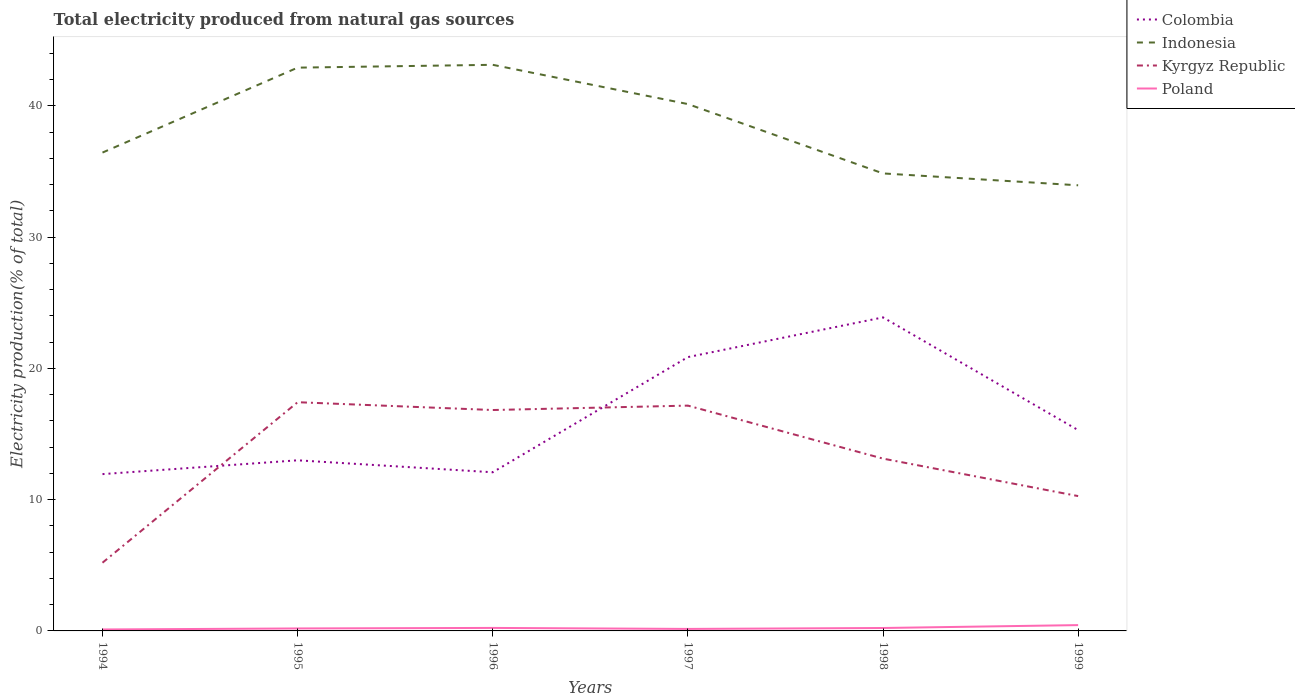Is the number of lines equal to the number of legend labels?
Provide a short and direct response. Yes. Across all years, what is the maximum total electricity produced in Colombia?
Offer a very short reply. 11.95. What is the total total electricity produced in Kyrgyz Republic in the graph?
Your response must be concise. -5.08. What is the difference between the highest and the second highest total electricity produced in Indonesia?
Your response must be concise. 9.18. How many years are there in the graph?
Provide a short and direct response. 6. Are the values on the major ticks of Y-axis written in scientific E-notation?
Offer a very short reply. No. Does the graph contain any zero values?
Offer a terse response. No. What is the title of the graph?
Keep it short and to the point. Total electricity produced from natural gas sources. What is the label or title of the X-axis?
Offer a terse response. Years. What is the label or title of the Y-axis?
Give a very brief answer. Electricity production(% of total). What is the Electricity production(% of total) of Colombia in 1994?
Your answer should be very brief. 11.95. What is the Electricity production(% of total) in Indonesia in 1994?
Keep it short and to the point. 36.44. What is the Electricity production(% of total) of Kyrgyz Republic in 1994?
Give a very brief answer. 5.2. What is the Electricity production(% of total) of Poland in 1994?
Offer a terse response. 0.11. What is the Electricity production(% of total) of Colombia in 1995?
Your response must be concise. 13. What is the Electricity production(% of total) in Indonesia in 1995?
Your answer should be very brief. 42.91. What is the Electricity production(% of total) of Kyrgyz Republic in 1995?
Offer a very short reply. 17.42. What is the Electricity production(% of total) in Poland in 1995?
Provide a short and direct response. 0.19. What is the Electricity production(% of total) in Colombia in 1996?
Offer a very short reply. 12.09. What is the Electricity production(% of total) of Indonesia in 1996?
Give a very brief answer. 43.13. What is the Electricity production(% of total) of Kyrgyz Republic in 1996?
Provide a short and direct response. 16.83. What is the Electricity production(% of total) in Poland in 1996?
Provide a succinct answer. 0.23. What is the Electricity production(% of total) of Colombia in 1997?
Give a very brief answer. 20.86. What is the Electricity production(% of total) of Indonesia in 1997?
Your response must be concise. 40.14. What is the Electricity production(% of total) in Kyrgyz Republic in 1997?
Offer a very short reply. 17.16. What is the Electricity production(% of total) in Poland in 1997?
Ensure brevity in your answer.  0.15. What is the Electricity production(% of total) of Colombia in 1998?
Your response must be concise. 23.89. What is the Electricity production(% of total) of Indonesia in 1998?
Provide a short and direct response. 34.85. What is the Electricity production(% of total) of Kyrgyz Republic in 1998?
Keep it short and to the point. 13.13. What is the Electricity production(% of total) of Poland in 1998?
Keep it short and to the point. 0.22. What is the Electricity production(% of total) of Colombia in 1999?
Ensure brevity in your answer.  15.3. What is the Electricity production(% of total) of Indonesia in 1999?
Offer a very short reply. 33.95. What is the Electricity production(% of total) in Kyrgyz Republic in 1999?
Make the answer very short. 10.27. What is the Electricity production(% of total) of Poland in 1999?
Your answer should be very brief. 0.44. Across all years, what is the maximum Electricity production(% of total) in Colombia?
Offer a very short reply. 23.89. Across all years, what is the maximum Electricity production(% of total) of Indonesia?
Provide a succinct answer. 43.13. Across all years, what is the maximum Electricity production(% of total) in Kyrgyz Republic?
Provide a succinct answer. 17.42. Across all years, what is the maximum Electricity production(% of total) of Poland?
Offer a very short reply. 0.44. Across all years, what is the minimum Electricity production(% of total) of Colombia?
Make the answer very short. 11.95. Across all years, what is the minimum Electricity production(% of total) in Indonesia?
Keep it short and to the point. 33.95. Across all years, what is the minimum Electricity production(% of total) in Kyrgyz Republic?
Make the answer very short. 5.2. Across all years, what is the minimum Electricity production(% of total) in Poland?
Provide a succinct answer. 0.11. What is the total Electricity production(% of total) of Colombia in the graph?
Your answer should be very brief. 97.08. What is the total Electricity production(% of total) in Indonesia in the graph?
Give a very brief answer. 231.42. What is the total Electricity production(% of total) in Kyrgyz Republic in the graph?
Your response must be concise. 80.01. What is the total Electricity production(% of total) in Poland in the graph?
Your answer should be very brief. 1.35. What is the difference between the Electricity production(% of total) in Colombia in 1994 and that in 1995?
Your answer should be compact. -1.05. What is the difference between the Electricity production(% of total) in Indonesia in 1994 and that in 1995?
Your answer should be compact. -6.47. What is the difference between the Electricity production(% of total) in Kyrgyz Republic in 1994 and that in 1995?
Offer a terse response. -12.23. What is the difference between the Electricity production(% of total) in Poland in 1994 and that in 1995?
Make the answer very short. -0.08. What is the difference between the Electricity production(% of total) of Colombia in 1994 and that in 1996?
Make the answer very short. -0.14. What is the difference between the Electricity production(% of total) in Indonesia in 1994 and that in 1996?
Your response must be concise. -6.69. What is the difference between the Electricity production(% of total) in Kyrgyz Republic in 1994 and that in 1996?
Provide a succinct answer. -11.63. What is the difference between the Electricity production(% of total) of Poland in 1994 and that in 1996?
Your response must be concise. -0.12. What is the difference between the Electricity production(% of total) of Colombia in 1994 and that in 1997?
Give a very brief answer. -8.91. What is the difference between the Electricity production(% of total) of Indonesia in 1994 and that in 1997?
Your answer should be compact. -3.69. What is the difference between the Electricity production(% of total) in Kyrgyz Republic in 1994 and that in 1997?
Offer a very short reply. -11.97. What is the difference between the Electricity production(% of total) of Poland in 1994 and that in 1997?
Provide a succinct answer. -0.04. What is the difference between the Electricity production(% of total) in Colombia in 1994 and that in 1998?
Your response must be concise. -11.94. What is the difference between the Electricity production(% of total) of Indonesia in 1994 and that in 1998?
Ensure brevity in your answer.  1.59. What is the difference between the Electricity production(% of total) in Kyrgyz Republic in 1994 and that in 1998?
Offer a very short reply. -7.93. What is the difference between the Electricity production(% of total) in Poland in 1994 and that in 1998?
Your answer should be compact. -0.11. What is the difference between the Electricity production(% of total) in Colombia in 1994 and that in 1999?
Ensure brevity in your answer.  -3.35. What is the difference between the Electricity production(% of total) of Indonesia in 1994 and that in 1999?
Provide a succinct answer. 2.49. What is the difference between the Electricity production(% of total) of Kyrgyz Republic in 1994 and that in 1999?
Keep it short and to the point. -5.08. What is the difference between the Electricity production(% of total) in Poland in 1994 and that in 1999?
Your answer should be very brief. -0.33. What is the difference between the Electricity production(% of total) of Colombia in 1995 and that in 1996?
Make the answer very short. 0.91. What is the difference between the Electricity production(% of total) in Indonesia in 1995 and that in 1996?
Give a very brief answer. -0.22. What is the difference between the Electricity production(% of total) of Kyrgyz Republic in 1995 and that in 1996?
Offer a terse response. 0.6. What is the difference between the Electricity production(% of total) of Poland in 1995 and that in 1996?
Ensure brevity in your answer.  -0.04. What is the difference between the Electricity production(% of total) in Colombia in 1995 and that in 1997?
Offer a terse response. -7.86. What is the difference between the Electricity production(% of total) in Indonesia in 1995 and that in 1997?
Keep it short and to the point. 2.78. What is the difference between the Electricity production(% of total) of Kyrgyz Republic in 1995 and that in 1997?
Your answer should be compact. 0.26. What is the difference between the Electricity production(% of total) of Poland in 1995 and that in 1997?
Give a very brief answer. 0.04. What is the difference between the Electricity production(% of total) in Colombia in 1995 and that in 1998?
Offer a terse response. -10.89. What is the difference between the Electricity production(% of total) of Indonesia in 1995 and that in 1998?
Your answer should be very brief. 8.06. What is the difference between the Electricity production(% of total) in Kyrgyz Republic in 1995 and that in 1998?
Offer a terse response. 4.3. What is the difference between the Electricity production(% of total) of Poland in 1995 and that in 1998?
Keep it short and to the point. -0.03. What is the difference between the Electricity production(% of total) in Colombia in 1995 and that in 1999?
Your response must be concise. -2.3. What is the difference between the Electricity production(% of total) in Indonesia in 1995 and that in 1999?
Provide a succinct answer. 8.96. What is the difference between the Electricity production(% of total) in Kyrgyz Republic in 1995 and that in 1999?
Ensure brevity in your answer.  7.15. What is the difference between the Electricity production(% of total) in Poland in 1995 and that in 1999?
Offer a very short reply. -0.25. What is the difference between the Electricity production(% of total) of Colombia in 1996 and that in 1997?
Your answer should be very brief. -8.77. What is the difference between the Electricity production(% of total) in Indonesia in 1996 and that in 1997?
Your response must be concise. 2.99. What is the difference between the Electricity production(% of total) of Kyrgyz Republic in 1996 and that in 1997?
Your response must be concise. -0.34. What is the difference between the Electricity production(% of total) in Poland in 1996 and that in 1997?
Your answer should be compact. 0.08. What is the difference between the Electricity production(% of total) of Colombia in 1996 and that in 1998?
Provide a succinct answer. -11.8. What is the difference between the Electricity production(% of total) in Indonesia in 1996 and that in 1998?
Ensure brevity in your answer.  8.27. What is the difference between the Electricity production(% of total) in Kyrgyz Republic in 1996 and that in 1998?
Offer a very short reply. 3.7. What is the difference between the Electricity production(% of total) of Poland in 1996 and that in 1998?
Your answer should be very brief. 0.01. What is the difference between the Electricity production(% of total) of Colombia in 1996 and that in 1999?
Your answer should be very brief. -3.21. What is the difference between the Electricity production(% of total) of Indonesia in 1996 and that in 1999?
Ensure brevity in your answer.  9.18. What is the difference between the Electricity production(% of total) of Kyrgyz Republic in 1996 and that in 1999?
Give a very brief answer. 6.56. What is the difference between the Electricity production(% of total) of Poland in 1996 and that in 1999?
Make the answer very short. -0.21. What is the difference between the Electricity production(% of total) in Colombia in 1997 and that in 1998?
Provide a succinct answer. -3.02. What is the difference between the Electricity production(% of total) in Indonesia in 1997 and that in 1998?
Your answer should be very brief. 5.28. What is the difference between the Electricity production(% of total) in Kyrgyz Republic in 1997 and that in 1998?
Give a very brief answer. 4.04. What is the difference between the Electricity production(% of total) of Poland in 1997 and that in 1998?
Provide a succinct answer. -0.07. What is the difference between the Electricity production(% of total) of Colombia in 1997 and that in 1999?
Provide a succinct answer. 5.56. What is the difference between the Electricity production(% of total) in Indonesia in 1997 and that in 1999?
Offer a terse response. 6.19. What is the difference between the Electricity production(% of total) in Kyrgyz Republic in 1997 and that in 1999?
Offer a terse response. 6.89. What is the difference between the Electricity production(% of total) of Poland in 1997 and that in 1999?
Keep it short and to the point. -0.29. What is the difference between the Electricity production(% of total) of Colombia in 1998 and that in 1999?
Offer a very short reply. 8.59. What is the difference between the Electricity production(% of total) of Indonesia in 1998 and that in 1999?
Make the answer very short. 0.9. What is the difference between the Electricity production(% of total) in Kyrgyz Republic in 1998 and that in 1999?
Ensure brevity in your answer.  2.85. What is the difference between the Electricity production(% of total) in Poland in 1998 and that in 1999?
Ensure brevity in your answer.  -0.22. What is the difference between the Electricity production(% of total) in Colombia in 1994 and the Electricity production(% of total) in Indonesia in 1995?
Your answer should be very brief. -30.97. What is the difference between the Electricity production(% of total) in Colombia in 1994 and the Electricity production(% of total) in Kyrgyz Republic in 1995?
Your answer should be very brief. -5.48. What is the difference between the Electricity production(% of total) in Colombia in 1994 and the Electricity production(% of total) in Poland in 1995?
Offer a very short reply. 11.76. What is the difference between the Electricity production(% of total) of Indonesia in 1994 and the Electricity production(% of total) of Kyrgyz Republic in 1995?
Your answer should be very brief. 19.02. What is the difference between the Electricity production(% of total) in Indonesia in 1994 and the Electricity production(% of total) in Poland in 1995?
Offer a terse response. 36.25. What is the difference between the Electricity production(% of total) in Kyrgyz Republic in 1994 and the Electricity production(% of total) in Poland in 1995?
Offer a terse response. 5.01. What is the difference between the Electricity production(% of total) of Colombia in 1994 and the Electricity production(% of total) of Indonesia in 1996?
Ensure brevity in your answer.  -31.18. What is the difference between the Electricity production(% of total) of Colombia in 1994 and the Electricity production(% of total) of Kyrgyz Republic in 1996?
Provide a succinct answer. -4.88. What is the difference between the Electricity production(% of total) in Colombia in 1994 and the Electricity production(% of total) in Poland in 1996?
Make the answer very short. 11.72. What is the difference between the Electricity production(% of total) of Indonesia in 1994 and the Electricity production(% of total) of Kyrgyz Republic in 1996?
Give a very brief answer. 19.61. What is the difference between the Electricity production(% of total) in Indonesia in 1994 and the Electricity production(% of total) in Poland in 1996?
Provide a short and direct response. 36.21. What is the difference between the Electricity production(% of total) in Kyrgyz Republic in 1994 and the Electricity production(% of total) in Poland in 1996?
Offer a very short reply. 4.97. What is the difference between the Electricity production(% of total) of Colombia in 1994 and the Electricity production(% of total) of Indonesia in 1997?
Make the answer very short. -28.19. What is the difference between the Electricity production(% of total) in Colombia in 1994 and the Electricity production(% of total) in Kyrgyz Republic in 1997?
Offer a terse response. -5.22. What is the difference between the Electricity production(% of total) of Colombia in 1994 and the Electricity production(% of total) of Poland in 1997?
Your answer should be compact. 11.79. What is the difference between the Electricity production(% of total) in Indonesia in 1994 and the Electricity production(% of total) in Kyrgyz Republic in 1997?
Make the answer very short. 19.28. What is the difference between the Electricity production(% of total) in Indonesia in 1994 and the Electricity production(% of total) in Poland in 1997?
Offer a terse response. 36.29. What is the difference between the Electricity production(% of total) of Kyrgyz Republic in 1994 and the Electricity production(% of total) of Poland in 1997?
Offer a very short reply. 5.04. What is the difference between the Electricity production(% of total) in Colombia in 1994 and the Electricity production(% of total) in Indonesia in 1998?
Offer a very short reply. -22.91. What is the difference between the Electricity production(% of total) of Colombia in 1994 and the Electricity production(% of total) of Kyrgyz Republic in 1998?
Offer a very short reply. -1.18. What is the difference between the Electricity production(% of total) of Colombia in 1994 and the Electricity production(% of total) of Poland in 1998?
Keep it short and to the point. 11.72. What is the difference between the Electricity production(% of total) in Indonesia in 1994 and the Electricity production(% of total) in Kyrgyz Republic in 1998?
Offer a very short reply. 23.32. What is the difference between the Electricity production(% of total) in Indonesia in 1994 and the Electricity production(% of total) in Poland in 1998?
Give a very brief answer. 36.22. What is the difference between the Electricity production(% of total) in Kyrgyz Republic in 1994 and the Electricity production(% of total) in Poland in 1998?
Your response must be concise. 4.97. What is the difference between the Electricity production(% of total) in Colombia in 1994 and the Electricity production(% of total) in Indonesia in 1999?
Your answer should be very brief. -22. What is the difference between the Electricity production(% of total) of Colombia in 1994 and the Electricity production(% of total) of Kyrgyz Republic in 1999?
Provide a succinct answer. 1.67. What is the difference between the Electricity production(% of total) of Colombia in 1994 and the Electricity production(% of total) of Poland in 1999?
Ensure brevity in your answer.  11.5. What is the difference between the Electricity production(% of total) of Indonesia in 1994 and the Electricity production(% of total) of Kyrgyz Republic in 1999?
Make the answer very short. 26.17. What is the difference between the Electricity production(% of total) in Indonesia in 1994 and the Electricity production(% of total) in Poland in 1999?
Ensure brevity in your answer.  36. What is the difference between the Electricity production(% of total) in Kyrgyz Republic in 1994 and the Electricity production(% of total) in Poland in 1999?
Keep it short and to the point. 4.75. What is the difference between the Electricity production(% of total) in Colombia in 1995 and the Electricity production(% of total) in Indonesia in 1996?
Offer a terse response. -30.13. What is the difference between the Electricity production(% of total) of Colombia in 1995 and the Electricity production(% of total) of Kyrgyz Republic in 1996?
Offer a very short reply. -3.83. What is the difference between the Electricity production(% of total) in Colombia in 1995 and the Electricity production(% of total) in Poland in 1996?
Ensure brevity in your answer.  12.77. What is the difference between the Electricity production(% of total) in Indonesia in 1995 and the Electricity production(% of total) in Kyrgyz Republic in 1996?
Give a very brief answer. 26.08. What is the difference between the Electricity production(% of total) in Indonesia in 1995 and the Electricity production(% of total) in Poland in 1996?
Make the answer very short. 42.68. What is the difference between the Electricity production(% of total) of Kyrgyz Republic in 1995 and the Electricity production(% of total) of Poland in 1996?
Your response must be concise. 17.2. What is the difference between the Electricity production(% of total) in Colombia in 1995 and the Electricity production(% of total) in Indonesia in 1997?
Ensure brevity in your answer.  -27.14. What is the difference between the Electricity production(% of total) in Colombia in 1995 and the Electricity production(% of total) in Kyrgyz Republic in 1997?
Offer a very short reply. -4.17. What is the difference between the Electricity production(% of total) in Colombia in 1995 and the Electricity production(% of total) in Poland in 1997?
Give a very brief answer. 12.84. What is the difference between the Electricity production(% of total) of Indonesia in 1995 and the Electricity production(% of total) of Kyrgyz Republic in 1997?
Your response must be concise. 25.75. What is the difference between the Electricity production(% of total) of Indonesia in 1995 and the Electricity production(% of total) of Poland in 1997?
Make the answer very short. 42.76. What is the difference between the Electricity production(% of total) in Kyrgyz Republic in 1995 and the Electricity production(% of total) in Poland in 1997?
Offer a very short reply. 17.27. What is the difference between the Electricity production(% of total) of Colombia in 1995 and the Electricity production(% of total) of Indonesia in 1998?
Make the answer very short. -21.86. What is the difference between the Electricity production(% of total) in Colombia in 1995 and the Electricity production(% of total) in Kyrgyz Republic in 1998?
Your answer should be very brief. -0.13. What is the difference between the Electricity production(% of total) of Colombia in 1995 and the Electricity production(% of total) of Poland in 1998?
Your answer should be very brief. 12.78. What is the difference between the Electricity production(% of total) of Indonesia in 1995 and the Electricity production(% of total) of Kyrgyz Republic in 1998?
Offer a terse response. 29.78. What is the difference between the Electricity production(% of total) of Indonesia in 1995 and the Electricity production(% of total) of Poland in 1998?
Give a very brief answer. 42.69. What is the difference between the Electricity production(% of total) in Kyrgyz Republic in 1995 and the Electricity production(% of total) in Poland in 1998?
Provide a short and direct response. 17.2. What is the difference between the Electricity production(% of total) in Colombia in 1995 and the Electricity production(% of total) in Indonesia in 1999?
Keep it short and to the point. -20.95. What is the difference between the Electricity production(% of total) in Colombia in 1995 and the Electricity production(% of total) in Kyrgyz Republic in 1999?
Ensure brevity in your answer.  2.73. What is the difference between the Electricity production(% of total) of Colombia in 1995 and the Electricity production(% of total) of Poland in 1999?
Your answer should be very brief. 12.55. What is the difference between the Electricity production(% of total) in Indonesia in 1995 and the Electricity production(% of total) in Kyrgyz Republic in 1999?
Give a very brief answer. 32.64. What is the difference between the Electricity production(% of total) in Indonesia in 1995 and the Electricity production(% of total) in Poland in 1999?
Make the answer very short. 42.47. What is the difference between the Electricity production(% of total) of Kyrgyz Republic in 1995 and the Electricity production(% of total) of Poland in 1999?
Your answer should be compact. 16.98. What is the difference between the Electricity production(% of total) of Colombia in 1996 and the Electricity production(% of total) of Indonesia in 1997?
Give a very brief answer. -28.05. What is the difference between the Electricity production(% of total) of Colombia in 1996 and the Electricity production(% of total) of Kyrgyz Republic in 1997?
Provide a succinct answer. -5.08. What is the difference between the Electricity production(% of total) in Colombia in 1996 and the Electricity production(% of total) in Poland in 1997?
Offer a terse response. 11.93. What is the difference between the Electricity production(% of total) in Indonesia in 1996 and the Electricity production(% of total) in Kyrgyz Republic in 1997?
Offer a terse response. 25.96. What is the difference between the Electricity production(% of total) of Indonesia in 1996 and the Electricity production(% of total) of Poland in 1997?
Give a very brief answer. 42.98. What is the difference between the Electricity production(% of total) in Kyrgyz Republic in 1996 and the Electricity production(% of total) in Poland in 1997?
Your answer should be very brief. 16.68. What is the difference between the Electricity production(% of total) in Colombia in 1996 and the Electricity production(% of total) in Indonesia in 1998?
Offer a very short reply. -22.77. What is the difference between the Electricity production(% of total) in Colombia in 1996 and the Electricity production(% of total) in Kyrgyz Republic in 1998?
Your response must be concise. -1.04. What is the difference between the Electricity production(% of total) of Colombia in 1996 and the Electricity production(% of total) of Poland in 1998?
Give a very brief answer. 11.86. What is the difference between the Electricity production(% of total) in Indonesia in 1996 and the Electricity production(% of total) in Kyrgyz Republic in 1998?
Give a very brief answer. 30. What is the difference between the Electricity production(% of total) of Indonesia in 1996 and the Electricity production(% of total) of Poland in 1998?
Keep it short and to the point. 42.91. What is the difference between the Electricity production(% of total) in Kyrgyz Republic in 1996 and the Electricity production(% of total) in Poland in 1998?
Offer a very short reply. 16.61. What is the difference between the Electricity production(% of total) in Colombia in 1996 and the Electricity production(% of total) in Indonesia in 1999?
Keep it short and to the point. -21.86. What is the difference between the Electricity production(% of total) in Colombia in 1996 and the Electricity production(% of total) in Kyrgyz Republic in 1999?
Keep it short and to the point. 1.81. What is the difference between the Electricity production(% of total) of Colombia in 1996 and the Electricity production(% of total) of Poland in 1999?
Make the answer very short. 11.64. What is the difference between the Electricity production(% of total) of Indonesia in 1996 and the Electricity production(% of total) of Kyrgyz Republic in 1999?
Give a very brief answer. 32.86. What is the difference between the Electricity production(% of total) in Indonesia in 1996 and the Electricity production(% of total) in Poland in 1999?
Your response must be concise. 42.69. What is the difference between the Electricity production(% of total) of Kyrgyz Republic in 1996 and the Electricity production(% of total) of Poland in 1999?
Your response must be concise. 16.39. What is the difference between the Electricity production(% of total) in Colombia in 1997 and the Electricity production(% of total) in Indonesia in 1998?
Your answer should be very brief. -13.99. What is the difference between the Electricity production(% of total) in Colombia in 1997 and the Electricity production(% of total) in Kyrgyz Republic in 1998?
Give a very brief answer. 7.73. What is the difference between the Electricity production(% of total) of Colombia in 1997 and the Electricity production(% of total) of Poland in 1998?
Ensure brevity in your answer.  20.64. What is the difference between the Electricity production(% of total) of Indonesia in 1997 and the Electricity production(% of total) of Kyrgyz Republic in 1998?
Your answer should be compact. 27.01. What is the difference between the Electricity production(% of total) of Indonesia in 1997 and the Electricity production(% of total) of Poland in 1998?
Provide a short and direct response. 39.91. What is the difference between the Electricity production(% of total) of Kyrgyz Republic in 1997 and the Electricity production(% of total) of Poland in 1998?
Provide a succinct answer. 16.94. What is the difference between the Electricity production(% of total) of Colombia in 1997 and the Electricity production(% of total) of Indonesia in 1999?
Offer a very short reply. -13.09. What is the difference between the Electricity production(% of total) in Colombia in 1997 and the Electricity production(% of total) in Kyrgyz Republic in 1999?
Offer a very short reply. 10.59. What is the difference between the Electricity production(% of total) in Colombia in 1997 and the Electricity production(% of total) in Poland in 1999?
Keep it short and to the point. 20.42. What is the difference between the Electricity production(% of total) of Indonesia in 1997 and the Electricity production(% of total) of Kyrgyz Republic in 1999?
Provide a short and direct response. 29.86. What is the difference between the Electricity production(% of total) of Indonesia in 1997 and the Electricity production(% of total) of Poland in 1999?
Ensure brevity in your answer.  39.69. What is the difference between the Electricity production(% of total) of Kyrgyz Republic in 1997 and the Electricity production(% of total) of Poland in 1999?
Offer a very short reply. 16.72. What is the difference between the Electricity production(% of total) in Colombia in 1998 and the Electricity production(% of total) in Indonesia in 1999?
Your answer should be compact. -10.06. What is the difference between the Electricity production(% of total) of Colombia in 1998 and the Electricity production(% of total) of Kyrgyz Republic in 1999?
Your answer should be very brief. 13.61. What is the difference between the Electricity production(% of total) of Colombia in 1998 and the Electricity production(% of total) of Poland in 1999?
Ensure brevity in your answer.  23.44. What is the difference between the Electricity production(% of total) in Indonesia in 1998 and the Electricity production(% of total) in Kyrgyz Republic in 1999?
Give a very brief answer. 24.58. What is the difference between the Electricity production(% of total) of Indonesia in 1998 and the Electricity production(% of total) of Poland in 1999?
Make the answer very short. 34.41. What is the difference between the Electricity production(% of total) in Kyrgyz Republic in 1998 and the Electricity production(% of total) in Poland in 1999?
Your answer should be very brief. 12.68. What is the average Electricity production(% of total) of Colombia per year?
Offer a terse response. 16.18. What is the average Electricity production(% of total) in Indonesia per year?
Offer a very short reply. 38.57. What is the average Electricity production(% of total) of Kyrgyz Republic per year?
Provide a short and direct response. 13.34. What is the average Electricity production(% of total) in Poland per year?
Your answer should be very brief. 0.22. In the year 1994, what is the difference between the Electricity production(% of total) in Colombia and Electricity production(% of total) in Indonesia?
Offer a terse response. -24.5. In the year 1994, what is the difference between the Electricity production(% of total) in Colombia and Electricity production(% of total) in Kyrgyz Republic?
Ensure brevity in your answer.  6.75. In the year 1994, what is the difference between the Electricity production(% of total) in Colombia and Electricity production(% of total) in Poland?
Offer a terse response. 11.84. In the year 1994, what is the difference between the Electricity production(% of total) in Indonesia and Electricity production(% of total) in Kyrgyz Republic?
Your answer should be very brief. 31.25. In the year 1994, what is the difference between the Electricity production(% of total) in Indonesia and Electricity production(% of total) in Poland?
Your answer should be very brief. 36.33. In the year 1994, what is the difference between the Electricity production(% of total) of Kyrgyz Republic and Electricity production(% of total) of Poland?
Offer a terse response. 5.09. In the year 1995, what is the difference between the Electricity production(% of total) of Colombia and Electricity production(% of total) of Indonesia?
Your answer should be compact. -29.91. In the year 1995, what is the difference between the Electricity production(% of total) in Colombia and Electricity production(% of total) in Kyrgyz Republic?
Your answer should be compact. -4.43. In the year 1995, what is the difference between the Electricity production(% of total) of Colombia and Electricity production(% of total) of Poland?
Your response must be concise. 12.81. In the year 1995, what is the difference between the Electricity production(% of total) in Indonesia and Electricity production(% of total) in Kyrgyz Republic?
Provide a succinct answer. 25.49. In the year 1995, what is the difference between the Electricity production(% of total) in Indonesia and Electricity production(% of total) in Poland?
Offer a terse response. 42.72. In the year 1995, what is the difference between the Electricity production(% of total) of Kyrgyz Republic and Electricity production(% of total) of Poland?
Offer a terse response. 17.24. In the year 1996, what is the difference between the Electricity production(% of total) in Colombia and Electricity production(% of total) in Indonesia?
Ensure brevity in your answer.  -31.04. In the year 1996, what is the difference between the Electricity production(% of total) in Colombia and Electricity production(% of total) in Kyrgyz Republic?
Offer a very short reply. -4.74. In the year 1996, what is the difference between the Electricity production(% of total) in Colombia and Electricity production(% of total) in Poland?
Provide a succinct answer. 11.86. In the year 1996, what is the difference between the Electricity production(% of total) of Indonesia and Electricity production(% of total) of Kyrgyz Republic?
Your answer should be compact. 26.3. In the year 1996, what is the difference between the Electricity production(% of total) of Indonesia and Electricity production(% of total) of Poland?
Keep it short and to the point. 42.9. In the year 1996, what is the difference between the Electricity production(% of total) in Kyrgyz Republic and Electricity production(% of total) in Poland?
Provide a succinct answer. 16.6. In the year 1997, what is the difference between the Electricity production(% of total) of Colombia and Electricity production(% of total) of Indonesia?
Give a very brief answer. -19.28. In the year 1997, what is the difference between the Electricity production(% of total) in Colombia and Electricity production(% of total) in Kyrgyz Republic?
Offer a terse response. 3.7. In the year 1997, what is the difference between the Electricity production(% of total) of Colombia and Electricity production(% of total) of Poland?
Offer a terse response. 20.71. In the year 1997, what is the difference between the Electricity production(% of total) in Indonesia and Electricity production(% of total) in Kyrgyz Republic?
Keep it short and to the point. 22.97. In the year 1997, what is the difference between the Electricity production(% of total) of Indonesia and Electricity production(% of total) of Poland?
Give a very brief answer. 39.98. In the year 1997, what is the difference between the Electricity production(% of total) in Kyrgyz Republic and Electricity production(% of total) in Poland?
Offer a terse response. 17.01. In the year 1998, what is the difference between the Electricity production(% of total) of Colombia and Electricity production(% of total) of Indonesia?
Your answer should be compact. -10.97. In the year 1998, what is the difference between the Electricity production(% of total) of Colombia and Electricity production(% of total) of Kyrgyz Republic?
Provide a succinct answer. 10.76. In the year 1998, what is the difference between the Electricity production(% of total) in Colombia and Electricity production(% of total) in Poland?
Give a very brief answer. 23.66. In the year 1998, what is the difference between the Electricity production(% of total) of Indonesia and Electricity production(% of total) of Kyrgyz Republic?
Offer a very short reply. 21.73. In the year 1998, what is the difference between the Electricity production(% of total) in Indonesia and Electricity production(% of total) in Poland?
Your answer should be compact. 34.63. In the year 1998, what is the difference between the Electricity production(% of total) of Kyrgyz Republic and Electricity production(% of total) of Poland?
Make the answer very short. 12.9. In the year 1999, what is the difference between the Electricity production(% of total) of Colombia and Electricity production(% of total) of Indonesia?
Your answer should be compact. -18.65. In the year 1999, what is the difference between the Electricity production(% of total) of Colombia and Electricity production(% of total) of Kyrgyz Republic?
Provide a short and direct response. 5.03. In the year 1999, what is the difference between the Electricity production(% of total) of Colombia and Electricity production(% of total) of Poland?
Offer a terse response. 14.86. In the year 1999, what is the difference between the Electricity production(% of total) of Indonesia and Electricity production(% of total) of Kyrgyz Republic?
Offer a terse response. 23.68. In the year 1999, what is the difference between the Electricity production(% of total) of Indonesia and Electricity production(% of total) of Poland?
Your answer should be very brief. 33.51. In the year 1999, what is the difference between the Electricity production(% of total) of Kyrgyz Republic and Electricity production(% of total) of Poland?
Your answer should be very brief. 9.83. What is the ratio of the Electricity production(% of total) in Colombia in 1994 to that in 1995?
Make the answer very short. 0.92. What is the ratio of the Electricity production(% of total) of Indonesia in 1994 to that in 1995?
Your answer should be compact. 0.85. What is the ratio of the Electricity production(% of total) in Kyrgyz Republic in 1994 to that in 1995?
Your response must be concise. 0.3. What is the ratio of the Electricity production(% of total) in Poland in 1994 to that in 1995?
Ensure brevity in your answer.  0.59. What is the ratio of the Electricity production(% of total) in Colombia in 1994 to that in 1996?
Your answer should be very brief. 0.99. What is the ratio of the Electricity production(% of total) in Indonesia in 1994 to that in 1996?
Make the answer very short. 0.84. What is the ratio of the Electricity production(% of total) of Kyrgyz Republic in 1994 to that in 1996?
Provide a succinct answer. 0.31. What is the ratio of the Electricity production(% of total) of Poland in 1994 to that in 1996?
Offer a very short reply. 0.48. What is the ratio of the Electricity production(% of total) of Colombia in 1994 to that in 1997?
Keep it short and to the point. 0.57. What is the ratio of the Electricity production(% of total) in Indonesia in 1994 to that in 1997?
Offer a very short reply. 0.91. What is the ratio of the Electricity production(% of total) of Kyrgyz Republic in 1994 to that in 1997?
Keep it short and to the point. 0.3. What is the ratio of the Electricity production(% of total) of Poland in 1994 to that in 1997?
Give a very brief answer. 0.72. What is the ratio of the Electricity production(% of total) of Colombia in 1994 to that in 1998?
Ensure brevity in your answer.  0.5. What is the ratio of the Electricity production(% of total) of Indonesia in 1994 to that in 1998?
Offer a very short reply. 1.05. What is the ratio of the Electricity production(% of total) in Kyrgyz Republic in 1994 to that in 1998?
Provide a short and direct response. 0.4. What is the ratio of the Electricity production(% of total) in Poland in 1994 to that in 1998?
Your answer should be compact. 0.5. What is the ratio of the Electricity production(% of total) in Colombia in 1994 to that in 1999?
Offer a very short reply. 0.78. What is the ratio of the Electricity production(% of total) in Indonesia in 1994 to that in 1999?
Offer a terse response. 1.07. What is the ratio of the Electricity production(% of total) in Kyrgyz Republic in 1994 to that in 1999?
Offer a terse response. 0.51. What is the ratio of the Electricity production(% of total) in Poland in 1994 to that in 1999?
Your answer should be very brief. 0.25. What is the ratio of the Electricity production(% of total) in Colombia in 1995 to that in 1996?
Offer a very short reply. 1.08. What is the ratio of the Electricity production(% of total) of Indonesia in 1995 to that in 1996?
Offer a terse response. 0.99. What is the ratio of the Electricity production(% of total) of Kyrgyz Republic in 1995 to that in 1996?
Your response must be concise. 1.04. What is the ratio of the Electricity production(% of total) in Poland in 1995 to that in 1996?
Your answer should be very brief. 0.82. What is the ratio of the Electricity production(% of total) of Colombia in 1995 to that in 1997?
Ensure brevity in your answer.  0.62. What is the ratio of the Electricity production(% of total) of Indonesia in 1995 to that in 1997?
Provide a succinct answer. 1.07. What is the ratio of the Electricity production(% of total) of Kyrgyz Republic in 1995 to that in 1997?
Keep it short and to the point. 1.02. What is the ratio of the Electricity production(% of total) of Poland in 1995 to that in 1997?
Your response must be concise. 1.23. What is the ratio of the Electricity production(% of total) in Colombia in 1995 to that in 1998?
Offer a very short reply. 0.54. What is the ratio of the Electricity production(% of total) in Indonesia in 1995 to that in 1998?
Your response must be concise. 1.23. What is the ratio of the Electricity production(% of total) in Kyrgyz Republic in 1995 to that in 1998?
Keep it short and to the point. 1.33. What is the ratio of the Electricity production(% of total) of Poland in 1995 to that in 1998?
Keep it short and to the point. 0.85. What is the ratio of the Electricity production(% of total) in Colombia in 1995 to that in 1999?
Your answer should be very brief. 0.85. What is the ratio of the Electricity production(% of total) of Indonesia in 1995 to that in 1999?
Offer a terse response. 1.26. What is the ratio of the Electricity production(% of total) of Kyrgyz Republic in 1995 to that in 1999?
Your response must be concise. 1.7. What is the ratio of the Electricity production(% of total) in Poland in 1995 to that in 1999?
Your response must be concise. 0.43. What is the ratio of the Electricity production(% of total) of Colombia in 1996 to that in 1997?
Your answer should be compact. 0.58. What is the ratio of the Electricity production(% of total) of Indonesia in 1996 to that in 1997?
Provide a short and direct response. 1.07. What is the ratio of the Electricity production(% of total) of Kyrgyz Republic in 1996 to that in 1997?
Offer a very short reply. 0.98. What is the ratio of the Electricity production(% of total) in Poland in 1996 to that in 1997?
Keep it short and to the point. 1.5. What is the ratio of the Electricity production(% of total) of Colombia in 1996 to that in 1998?
Your response must be concise. 0.51. What is the ratio of the Electricity production(% of total) of Indonesia in 1996 to that in 1998?
Provide a short and direct response. 1.24. What is the ratio of the Electricity production(% of total) in Kyrgyz Republic in 1996 to that in 1998?
Give a very brief answer. 1.28. What is the ratio of the Electricity production(% of total) in Poland in 1996 to that in 1998?
Your response must be concise. 1.03. What is the ratio of the Electricity production(% of total) of Colombia in 1996 to that in 1999?
Your answer should be compact. 0.79. What is the ratio of the Electricity production(% of total) in Indonesia in 1996 to that in 1999?
Give a very brief answer. 1.27. What is the ratio of the Electricity production(% of total) in Kyrgyz Republic in 1996 to that in 1999?
Ensure brevity in your answer.  1.64. What is the ratio of the Electricity production(% of total) of Poland in 1996 to that in 1999?
Offer a very short reply. 0.52. What is the ratio of the Electricity production(% of total) in Colombia in 1997 to that in 1998?
Keep it short and to the point. 0.87. What is the ratio of the Electricity production(% of total) of Indonesia in 1997 to that in 1998?
Offer a very short reply. 1.15. What is the ratio of the Electricity production(% of total) of Kyrgyz Republic in 1997 to that in 1998?
Your response must be concise. 1.31. What is the ratio of the Electricity production(% of total) in Poland in 1997 to that in 1998?
Ensure brevity in your answer.  0.69. What is the ratio of the Electricity production(% of total) in Colombia in 1997 to that in 1999?
Provide a succinct answer. 1.36. What is the ratio of the Electricity production(% of total) in Indonesia in 1997 to that in 1999?
Keep it short and to the point. 1.18. What is the ratio of the Electricity production(% of total) of Kyrgyz Republic in 1997 to that in 1999?
Make the answer very short. 1.67. What is the ratio of the Electricity production(% of total) in Poland in 1997 to that in 1999?
Your answer should be very brief. 0.34. What is the ratio of the Electricity production(% of total) of Colombia in 1998 to that in 1999?
Your answer should be compact. 1.56. What is the ratio of the Electricity production(% of total) in Indonesia in 1998 to that in 1999?
Your response must be concise. 1.03. What is the ratio of the Electricity production(% of total) of Kyrgyz Republic in 1998 to that in 1999?
Provide a succinct answer. 1.28. What is the ratio of the Electricity production(% of total) in Poland in 1998 to that in 1999?
Offer a very short reply. 0.5. What is the difference between the highest and the second highest Electricity production(% of total) of Colombia?
Provide a succinct answer. 3.02. What is the difference between the highest and the second highest Electricity production(% of total) of Indonesia?
Provide a short and direct response. 0.22. What is the difference between the highest and the second highest Electricity production(% of total) of Kyrgyz Republic?
Your answer should be compact. 0.26. What is the difference between the highest and the second highest Electricity production(% of total) in Poland?
Your answer should be very brief. 0.21. What is the difference between the highest and the lowest Electricity production(% of total) of Colombia?
Your answer should be compact. 11.94. What is the difference between the highest and the lowest Electricity production(% of total) of Indonesia?
Ensure brevity in your answer.  9.18. What is the difference between the highest and the lowest Electricity production(% of total) of Kyrgyz Republic?
Provide a succinct answer. 12.23. What is the difference between the highest and the lowest Electricity production(% of total) of Poland?
Offer a very short reply. 0.33. 